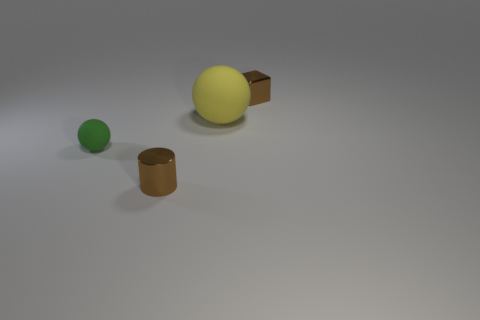Are there any things that have the same color as the tiny cube?
Keep it short and to the point. Yes. Is there another tiny matte object of the same shape as the yellow object?
Provide a short and direct response. Yes. There is a thing that is in front of the small brown cube and right of the tiny cylinder; what shape is it?
Keep it short and to the point. Sphere. What number of other large balls have the same material as the green sphere?
Keep it short and to the point. 1. Is the number of shiny cubes that are in front of the tiny green matte sphere less than the number of brown shiny cylinders?
Make the answer very short. Yes. There is a thing in front of the tiny green ball; are there any tiny things that are behind it?
Offer a very short reply. Yes. Is the size of the brown cylinder the same as the green matte ball?
Provide a succinct answer. Yes. There is a brown thing on the right side of the tiny brown shiny thing that is on the left side of the tiny brown thing that is behind the green ball; what is it made of?
Provide a succinct answer. Metal. Are there the same number of yellow rubber balls left of the small green matte ball and big blue rubber things?
Offer a terse response. Yes. Is there any other thing that has the same size as the yellow rubber thing?
Your answer should be very brief. No. 